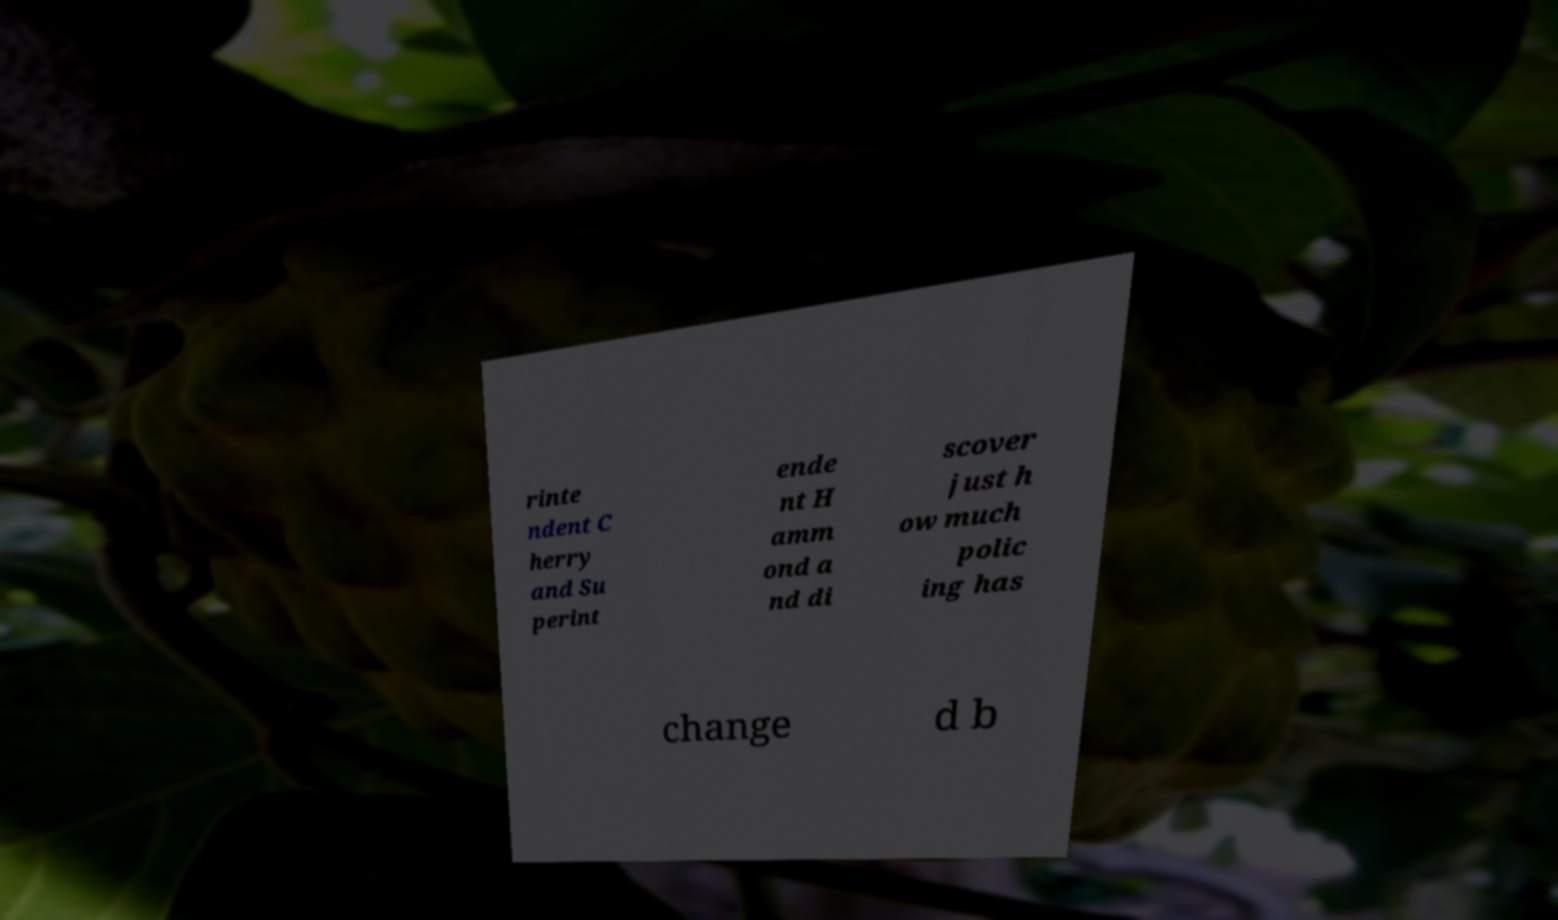For documentation purposes, I need the text within this image transcribed. Could you provide that? rinte ndent C herry and Su perint ende nt H amm ond a nd di scover just h ow much polic ing has change d b 